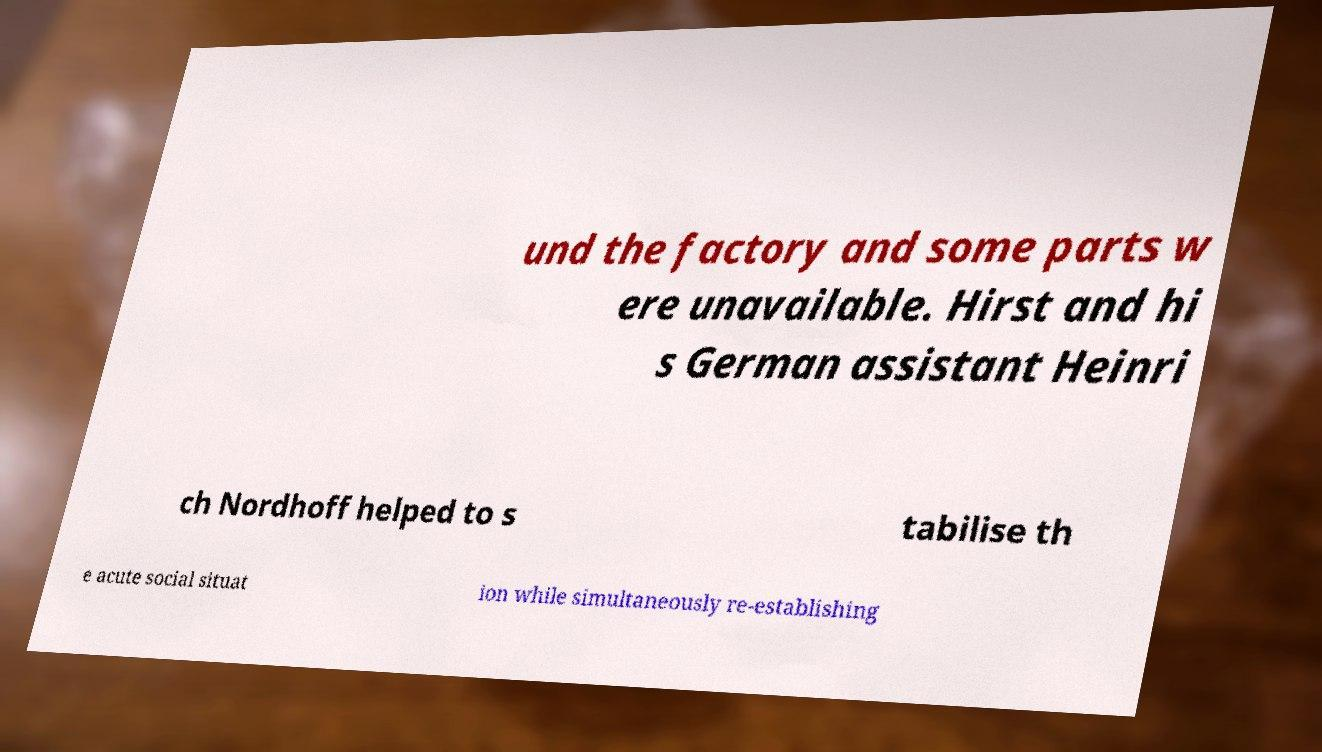Could you extract and type out the text from this image? und the factory and some parts w ere unavailable. Hirst and hi s German assistant Heinri ch Nordhoff helped to s tabilise th e acute social situat ion while simultaneously re-establishing 